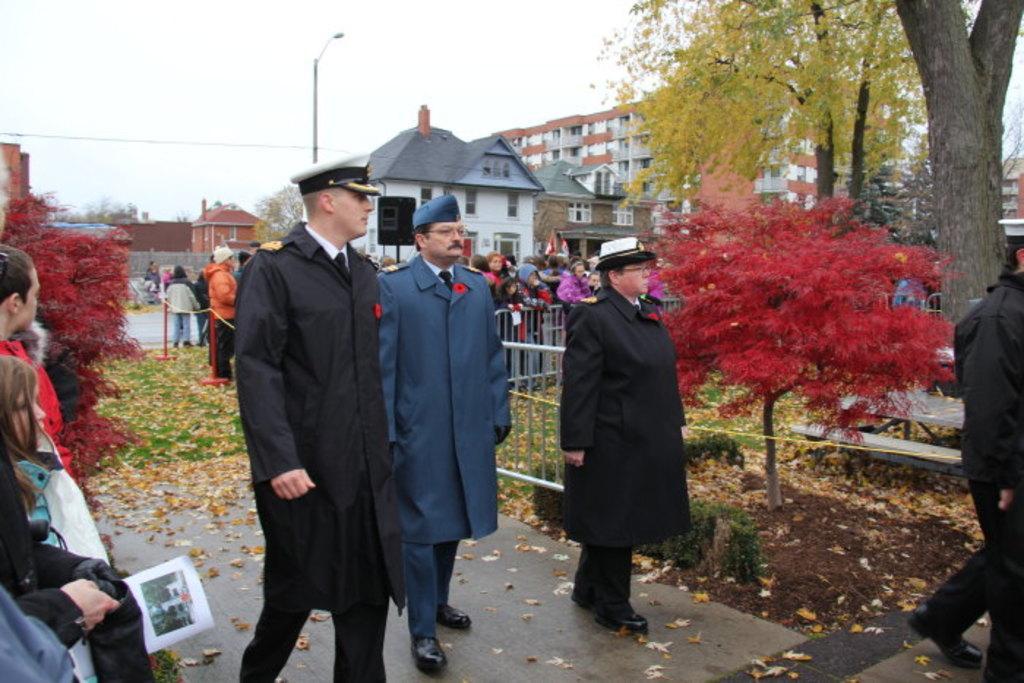Describe this image in one or two sentences. In this image in the center there are three persons who are walking, and at the bottom there is a walkway grass and some leaves. And in the background there are some houses and pole and one light and also on the right side there are some trees and a bench. On the left side there are some people who are standing, and there are some trees. On the top of the image there is sky. 